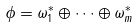<formula> <loc_0><loc_0><loc_500><loc_500>\phi = \omega _ { 1 } ^ { * } \oplus \cdots \oplus \omega _ { m } ^ { * }</formula> 